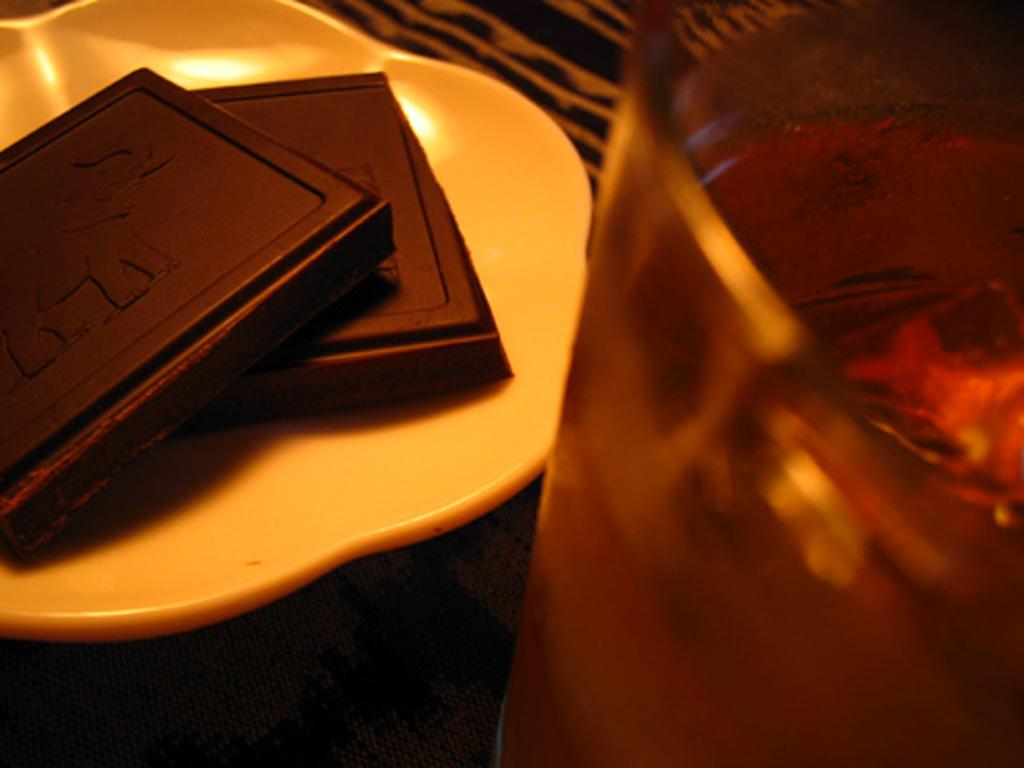What is on the plate in the image? There are food items on a plate in the image. Can you describe the object on the right side of the image? Unfortunately, the provided facts do not give any information about the object on the right side of the image. How many achievers are visible in the image? There is no mention of achievers in the provided facts, so we cannot determine if any are visible in the image. 